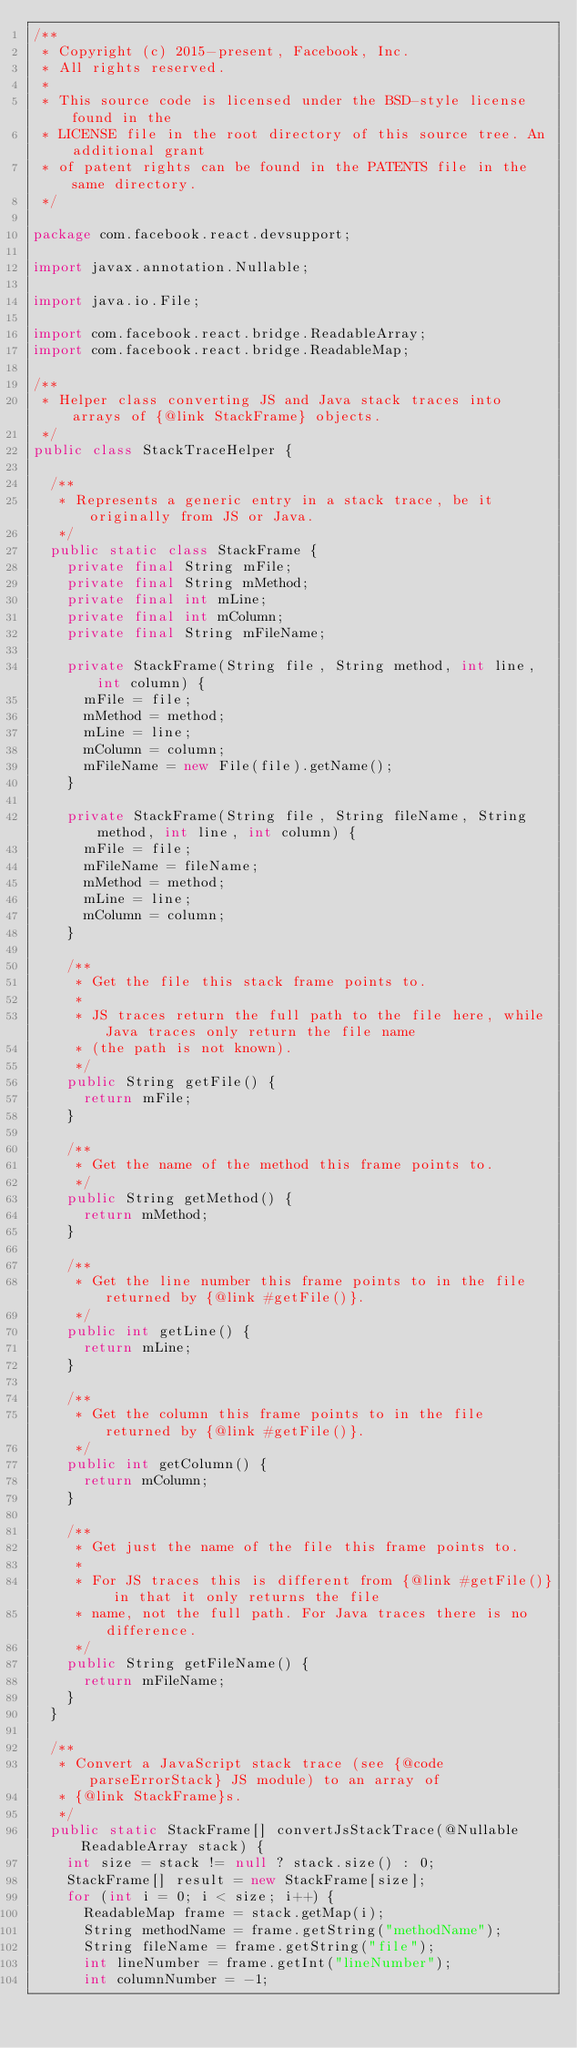<code> <loc_0><loc_0><loc_500><loc_500><_Java_>/**
 * Copyright (c) 2015-present, Facebook, Inc.
 * All rights reserved.
 *
 * This source code is licensed under the BSD-style license found in the
 * LICENSE file in the root directory of this source tree. An additional grant
 * of patent rights can be found in the PATENTS file in the same directory.
 */

package com.facebook.react.devsupport;

import javax.annotation.Nullable;

import java.io.File;

import com.facebook.react.bridge.ReadableArray;
import com.facebook.react.bridge.ReadableMap;

/**
 * Helper class converting JS and Java stack traces into arrays of {@link StackFrame} objects.
 */
public class StackTraceHelper {

  /**
   * Represents a generic entry in a stack trace, be it originally from JS or Java.
   */
  public static class StackFrame {
    private final String mFile;
    private final String mMethod;
    private final int mLine;
    private final int mColumn;
    private final String mFileName;

    private StackFrame(String file, String method, int line, int column) {
      mFile = file;
      mMethod = method;
      mLine = line;
      mColumn = column;
      mFileName = new File(file).getName();
    }

    private StackFrame(String file, String fileName, String method, int line, int column) {
      mFile = file;
      mFileName = fileName;
      mMethod = method;
      mLine = line;
      mColumn = column;
    }

    /**
     * Get the file this stack frame points to.
     *
     * JS traces return the full path to the file here, while Java traces only return the file name
     * (the path is not known).
     */
    public String getFile() {
      return mFile;
    }

    /**
     * Get the name of the method this frame points to.
     */
    public String getMethod() {
      return mMethod;
    }

    /**
     * Get the line number this frame points to in the file returned by {@link #getFile()}.
     */
    public int getLine() {
      return mLine;
    }

    /**
     * Get the column this frame points to in the file returned by {@link #getFile()}.
     */
    public int getColumn() {
      return mColumn;
    }

    /**
     * Get just the name of the file this frame points to.
     *
     * For JS traces this is different from {@link #getFile()} in that it only returns the file
     * name, not the full path. For Java traces there is no difference.
     */
    public String getFileName() {
      return mFileName;
    }
  }

  /**
   * Convert a JavaScript stack trace (see {@code parseErrorStack} JS module) to an array of
   * {@link StackFrame}s.
   */
  public static StackFrame[] convertJsStackTrace(@Nullable ReadableArray stack) {
    int size = stack != null ? stack.size() : 0;
    StackFrame[] result = new StackFrame[size];
    for (int i = 0; i < size; i++) {
      ReadableMap frame = stack.getMap(i);
      String methodName = frame.getString("methodName");
      String fileName = frame.getString("file");
      int lineNumber = frame.getInt("lineNumber");
      int columnNumber = -1;</code> 